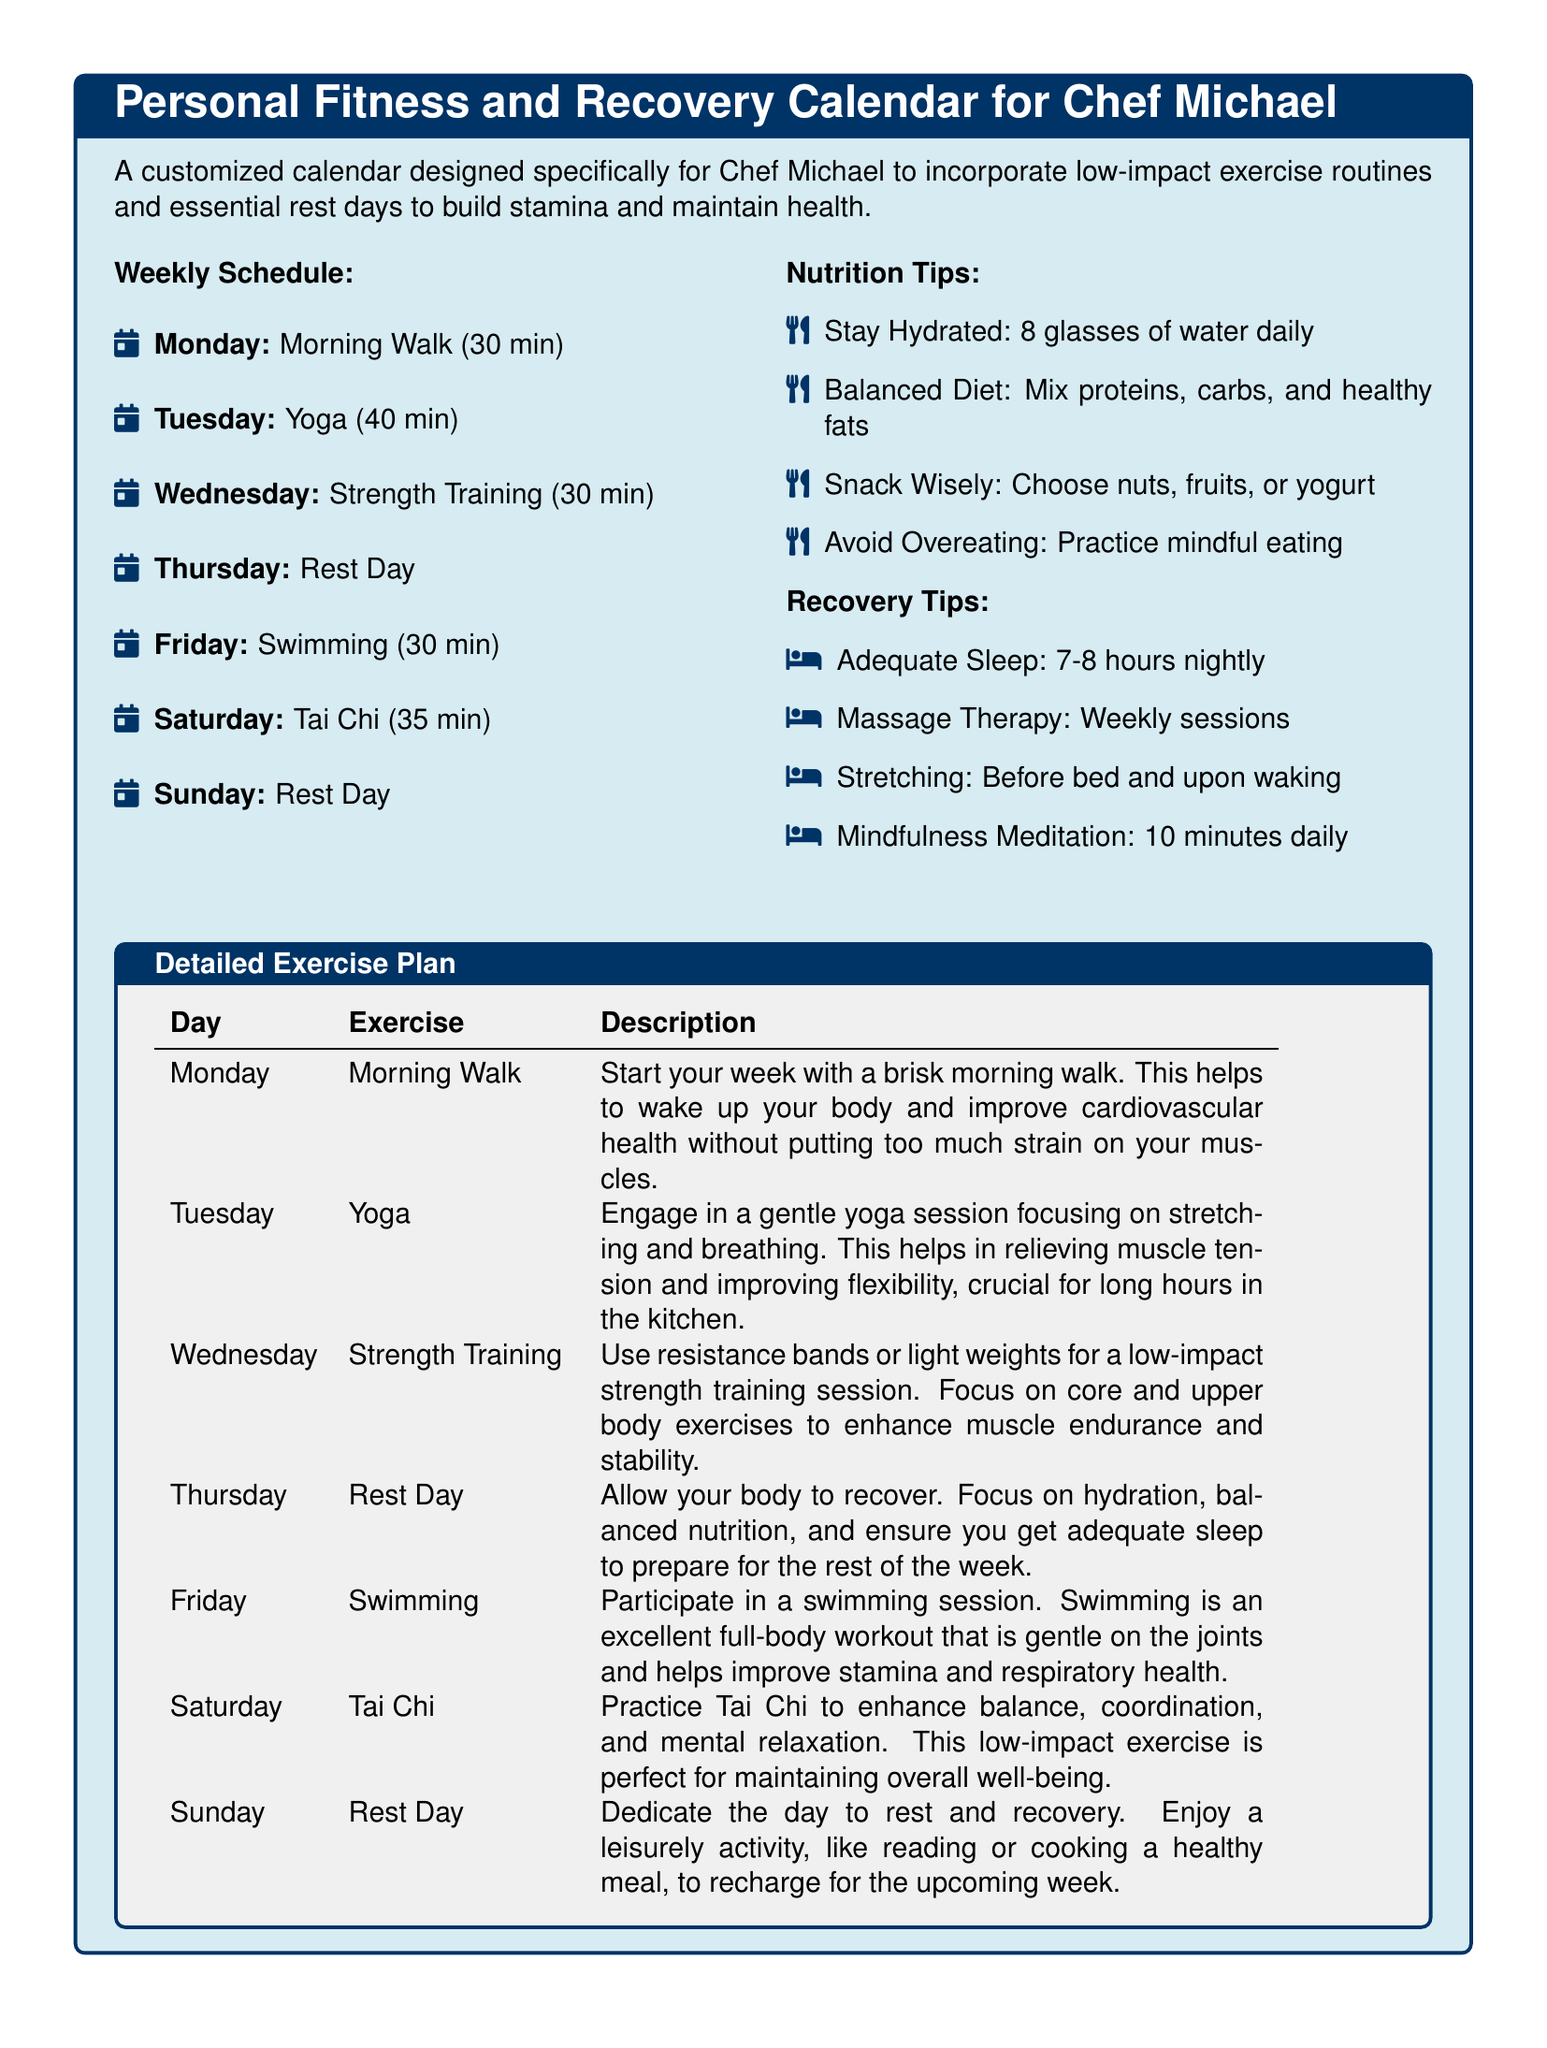What is the duration of the Monday exercise? The Monday exercise is a morning walk that lasts for 30 minutes.
Answer: 30 min What type of exercise is scheduled for Tuesday? The exercise scheduled for Tuesday is yoga, which focuses on stretching and breathing.
Answer: Yoga How many rest days are included in the weekly schedule? The weekly schedule includes two rest days to allow for recovery.
Answer: 2 What is the weekly recommended water intake? The document suggests that one should stay hydrated by drinking 8 glasses of water daily.
Answer: 8 glasses Which day is designated as a swimming day? The exercise scheduled for Friday is swimming, providing a full-body workout.
Answer: Friday What is the total duration of Tai Chi on Saturday? The duration of Tai Chi on Saturday is 35 minutes, aimed at improving balance and relaxation.
Answer: 35 min What is suggested as a recovery tip? One of the recovery tips includes practicing mindfulness meditation for 10 minutes daily.
Answer: Mindfulness Meditation What should be the focus on Thursday? Thursday is designated as a rest day, which emphasizes recovery and hydration.
Answer: Rest Day What type of physical activity is highlighted for improving flexibility? The exercise aimed at improving flexibility is yoga, planned for Tuesday.
Answer: Yoga 